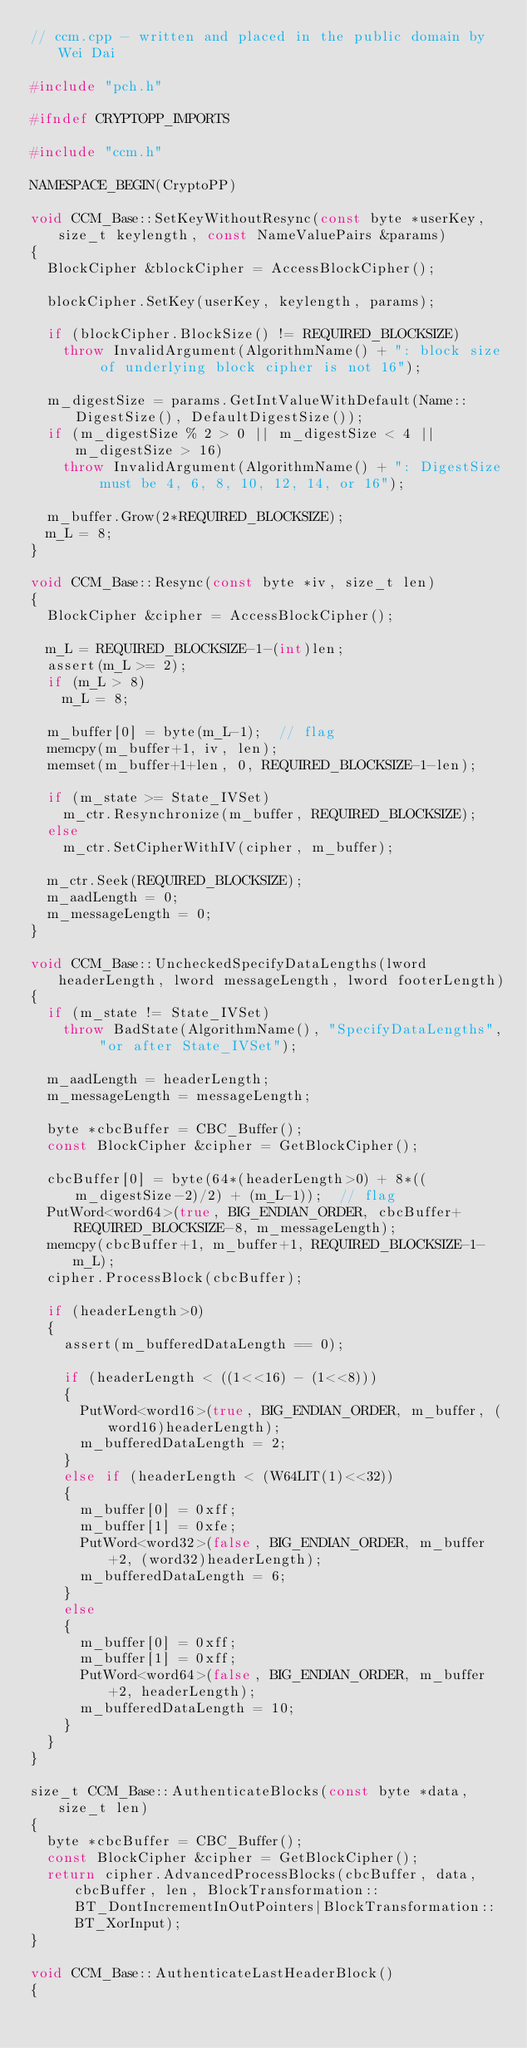<code> <loc_0><loc_0><loc_500><loc_500><_C++_>// ccm.cpp - written and placed in the public domain by Wei Dai

#include "pch.h"

#ifndef CRYPTOPP_IMPORTS

#include "ccm.h"

NAMESPACE_BEGIN(CryptoPP)

void CCM_Base::SetKeyWithoutResync(const byte *userKey, size_t keylength, const NameValuePairs &params)
{
	BlockCipher &blockCipher = AccessBlockCipher();

	blockCipher.SetKey(userKey, keylength, params);

	if (blockCipher.BlockSize() != REQUIRED_BLOCKSIZE)
		throw InvalidArgument(AlgorithmName() + ": block size of underlying block cipher is not 16");

	m_digestSize = params.GetIntValueWithDefault(Name::DigestSize(), DefaultDigestSize());
	if (m_digestSize % 2 > 0 || m_digestSize < 4 || m_digestSize > 16)
		throw InvalidArgument(AlgorithmName() + ": DigestSize must be 4, 6, 8, 10, 12, 14, or 16");

	m_buffer.Grow(2*REQUIRED_BLOCKSIZE);
	m_L = 8;
}

void CCM_Base::Resync(const byte *iv, size_t len)
{
	BlockCipher &cipher = AccessBlockCipher();

	m_L = REQUIRED_BLOCKSIZE-1-(int)len;
	assert(m_L >= 2);
	if (m_L > 8)
		m_L = 8;

	m_buffer[0] = byte(m_L-1);	// flag
	memcpy(m_buffer+1, iv, len);
	memset(m_buffer+1+len, 0, REQUIRED_BLOCKSIZE-1-len);

	if (m_state >= State_IVSet)
		m_ctr.Resynchronize(m_buffer, REQUIRED_BLOCKSIZE);
	else
		m_ctr.SetCipherWithIV(cipher, m_buffer);

	m_ctr.Seek(REQUIRED_BLOCKSIZE);
	m_aadLength = 0; 
	m_messageLength = 0;
}

void CCM_Base::UncheckedSpecifyDataLengths(lword headerLength, lword messageLength, lword footerLength)
{
	if (m_state != State_IVSet)
		throw BadState(AlgorithmName(), "SpecifyDataLengths", "or after State_IVSet");

	m_aadLength = headerLength; 
	m_messageLength = messageLength;

	byte *cbcBuffer = CBC_Buffer();
	const BlockCipher &cipher = GetBlockCipher();

	cbcBuffer[0] = byte(64*(headerLength>0) + 8*((m_digestSize-2)/2) + (m_L-1));	// flag
	PutWord<word64>(true, BIG_ENDIAN_ORDER, cbcBuffer+REQUIRED_BLOCKSIZE-8, m_messageLength);
	memcpy(cbcBuffer+1, m_buffer+1, REQUIRED_BLOCKSIZE-1-m_L);
	cipher.ProcessBlock(cbcBuffer);

	if (headerLength>0)
	{
		assert(m_bufferedDataLength == 0);

		if (headerLength < ((1<<16) - (1<<8)))
		{
			PutWord<word16>(true, BIG_ENDIAN_ORDER, m_buffer, (word16)headerLength);
			m_bufferedDataLength = 2;
		}
		else if (headerLength < (W64LIT(1)<<32))
		{
			m_buffer[0] = 0xff;
			m_buffer[1] = 0xfe;
			PutWord<word32>(false, BIG_ENDIAN_ORDER, m_buffer+2, (word32)headerLength);
			m_bufferedDataLength = 6;
		}
		else
		{
			m_buffer[0] = 0xff;
			m_buffer[1] = 0xff;
			PutWord<word64>(false, BIG_ENDIAN_ORDER, m_buffer+2, headerLength);
			m_bufferedDataLength = 10;
		}
	}
}

size_t CCM_Base::AuthenticateBlocks(const byte *data, size_t len)
{
	byte *cbcBuffer = CBC_Buffer();
	const BlockCipher &cipher = GetBlockCipher();
	return cipher.AdvancedProcessBlocks(cbcBuffer, data, cbcBuffer, len, BlockTransformation::BT_DontIncrementInOutPointers|BlockTransformation::BT_XorInput);
}

void CCM_Base::AuthenticateLastHeaderBlock()
{</code> 